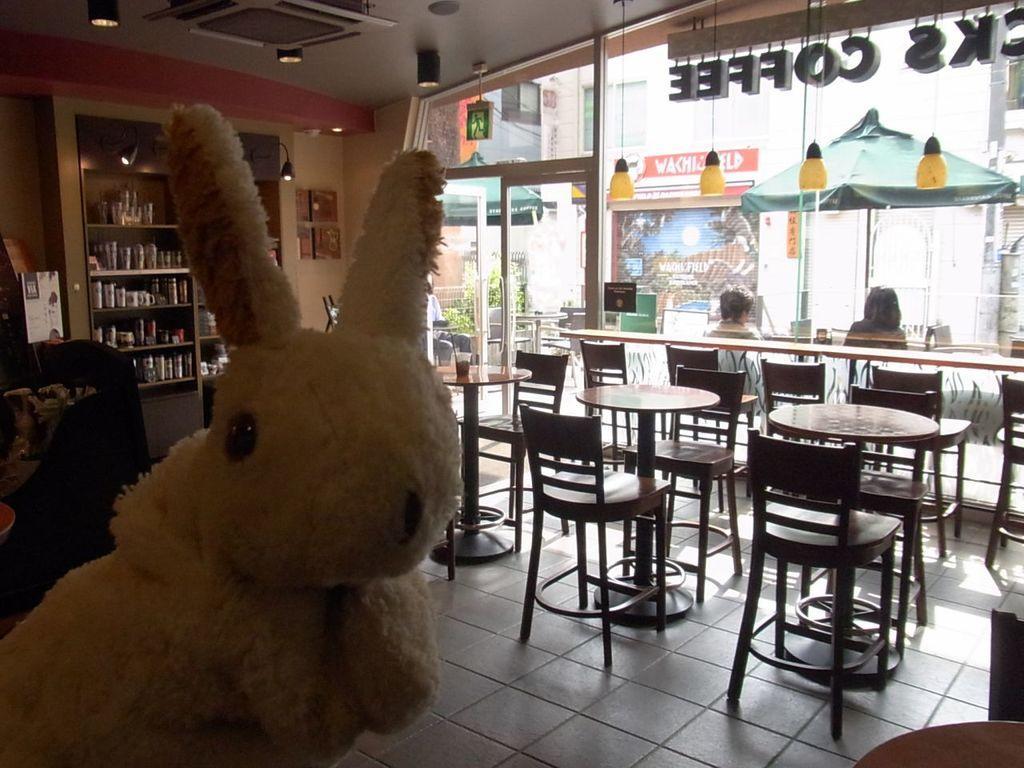Can you describe this image briefly? In the image we can see there is a rabbit toy and there are tables and chairs and there are two persons sitting here and at the back there is a shelf in which there are cups, bottles, glasses. 